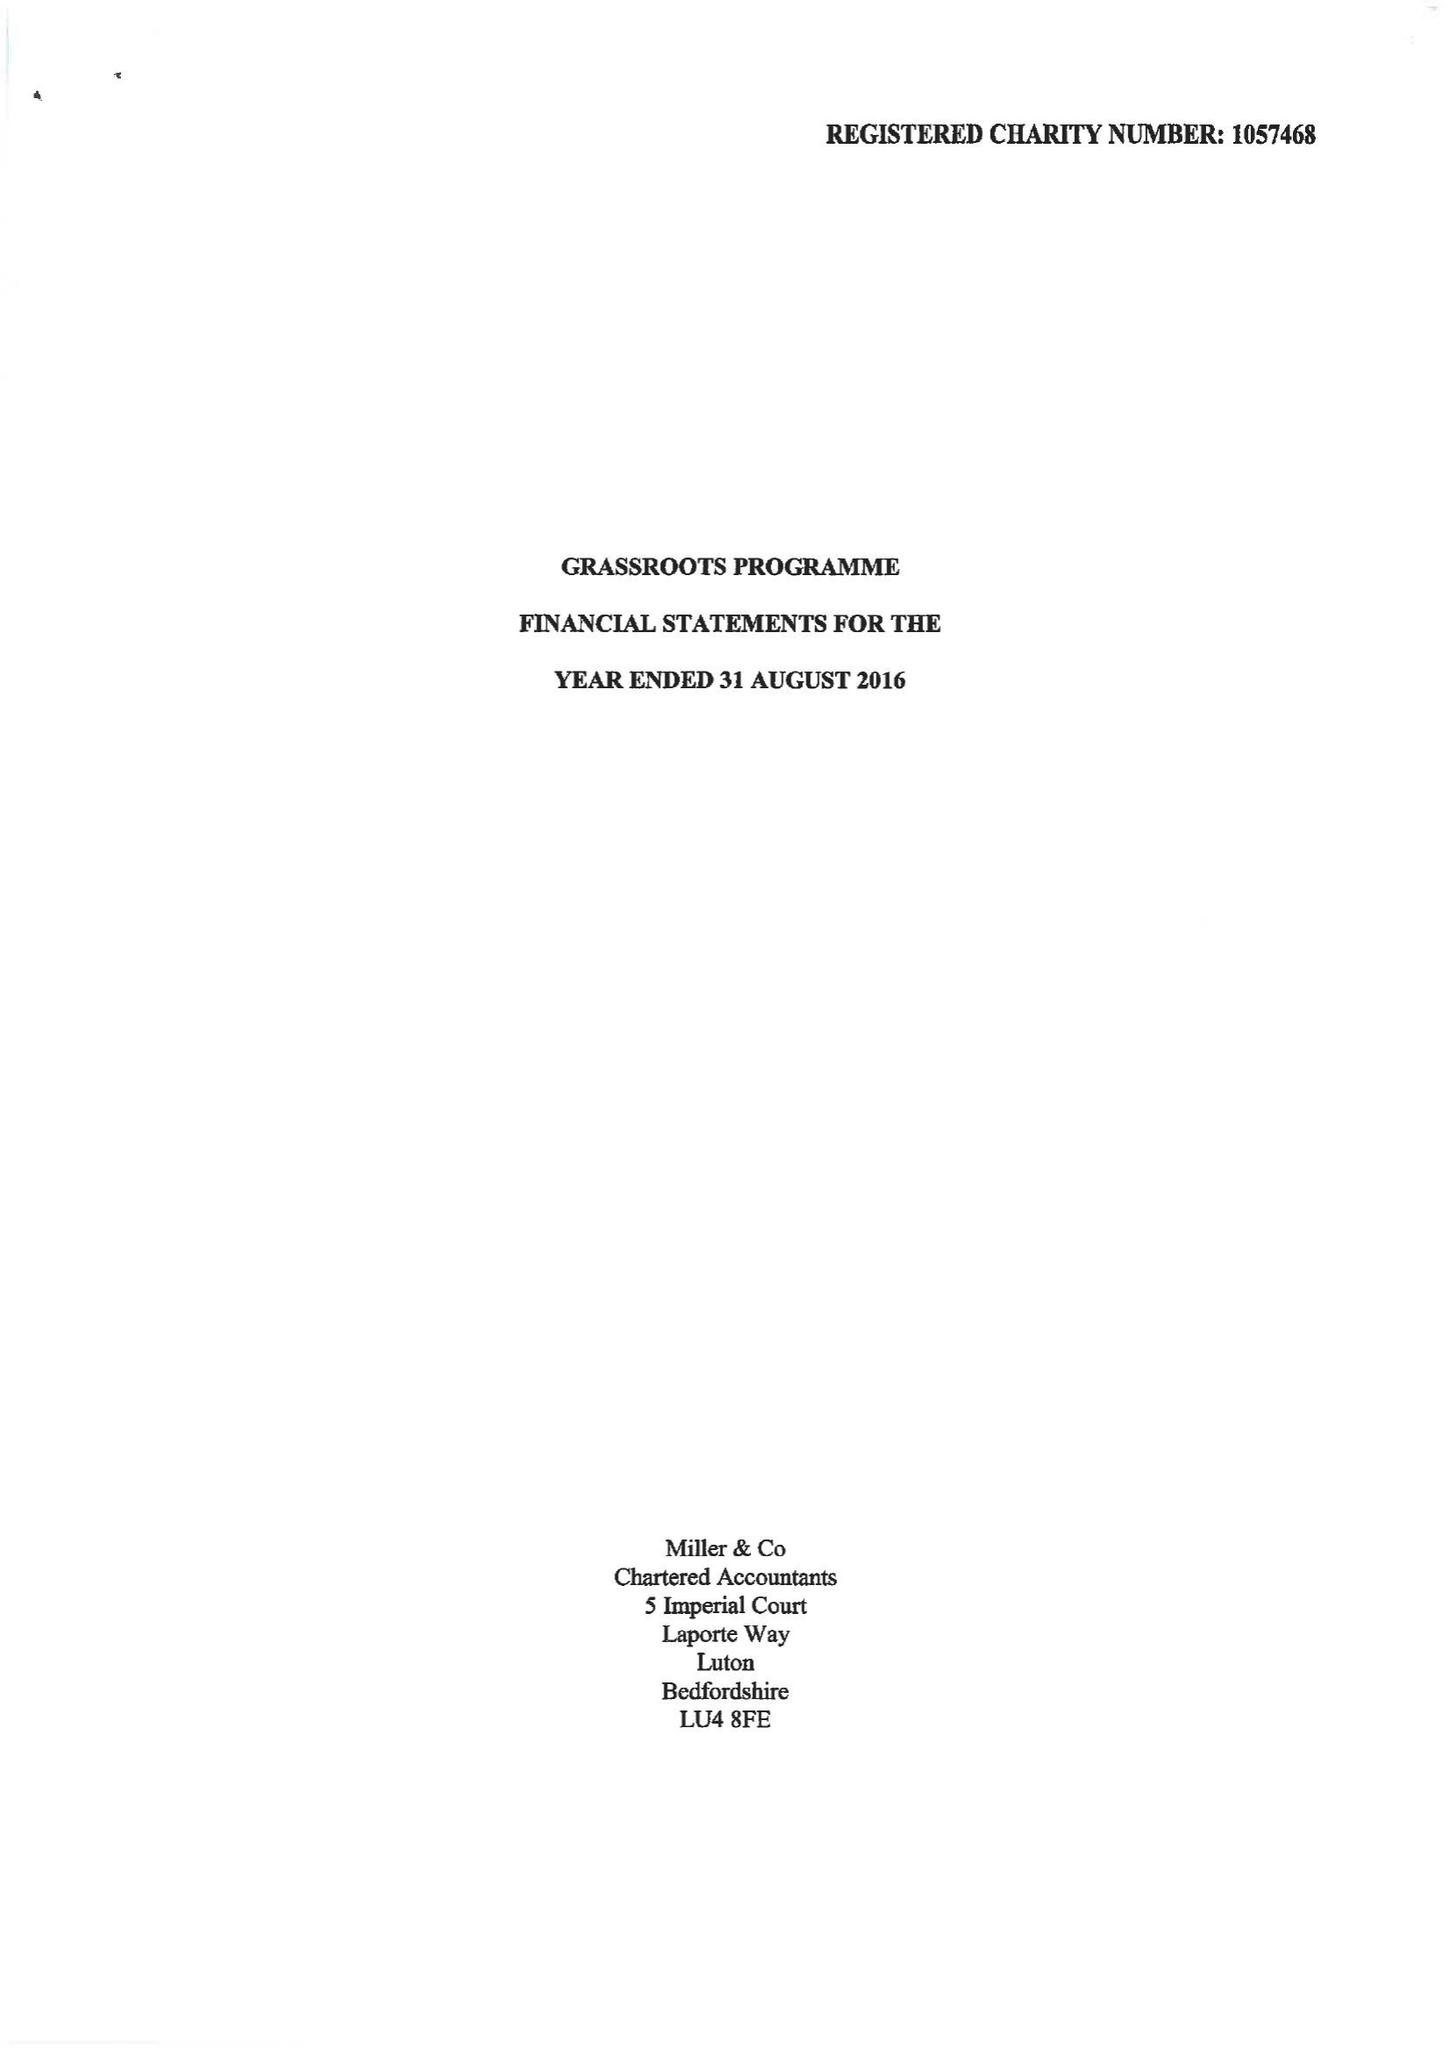What is the value for the address__post_town?
Answer the question using a single word or phrase. LUTON 